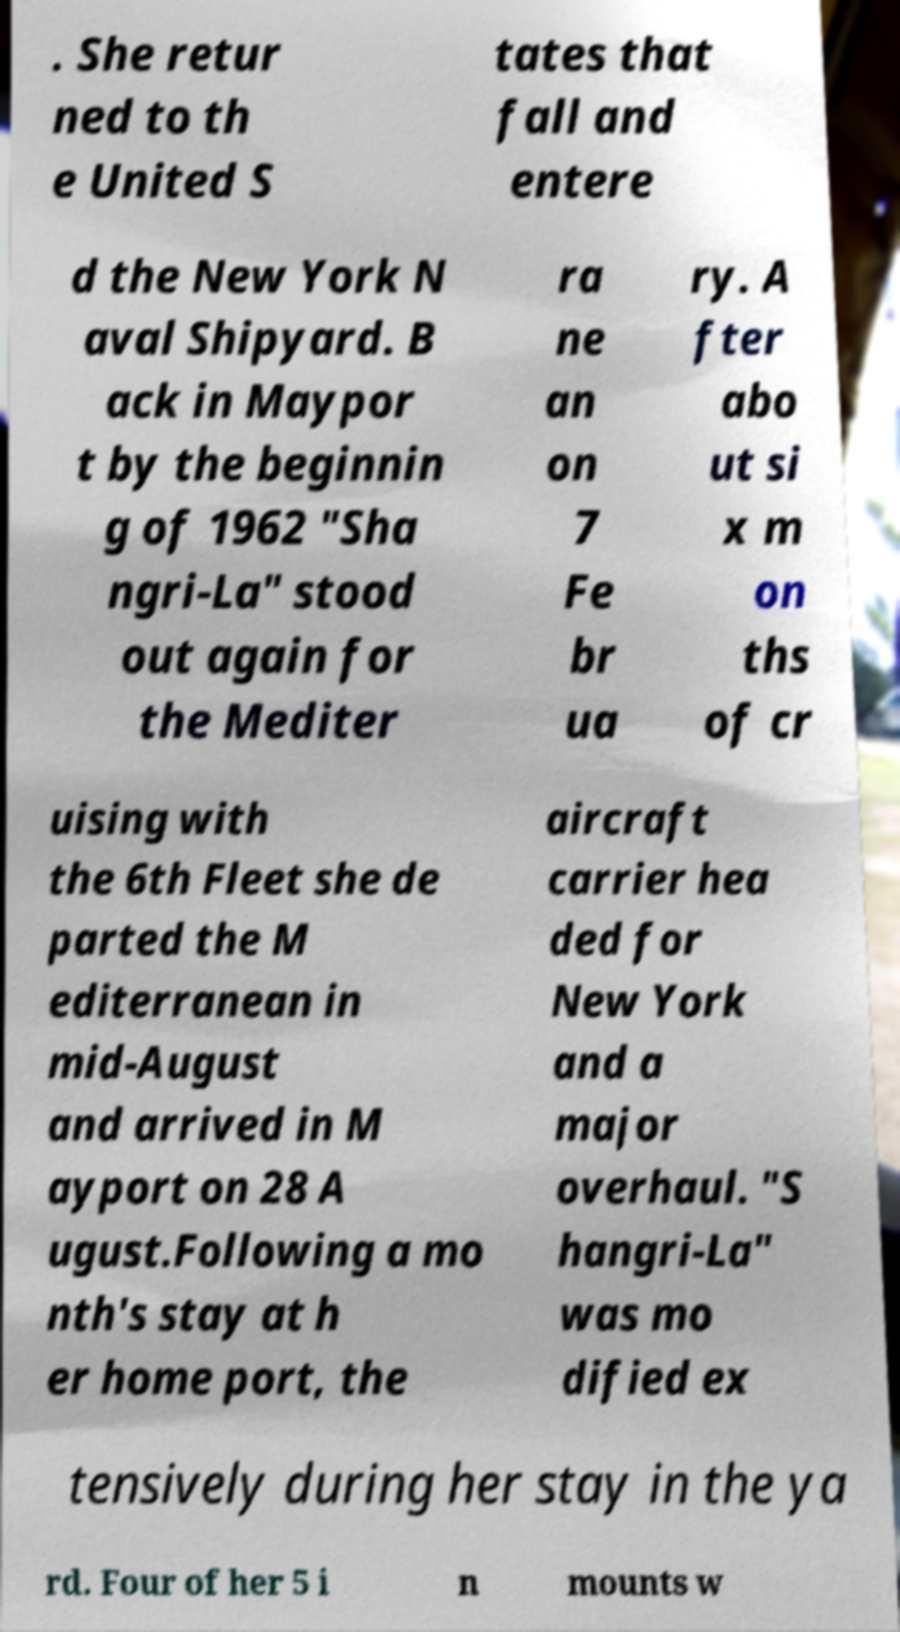Can you read and provide the text displayed in the image?This photo seems to have some interesting text. Can you extract and type it out for me? . She retur ned to th e United S tates that fall and entere d the New York N aval Shipyard. B ack in Maypor t by the beginnin g of 1962 "Sha ngri-La" stood out again for the Mediter ra ne an on 7 Fe br ua ry. A fter abo ut si x m on ths of cr uising with the 6th Fleet she de parted the M editerranean in mid-August and arrived in M ayport on 28 A ugust.Following a mo nth's stay at h er home port, the aircraft carrier hea ded for New York and a major overhaul. "S hangri-La" was mo dified ex tensively during her stay in the ya rd. Four of her 5 i n mounts w 